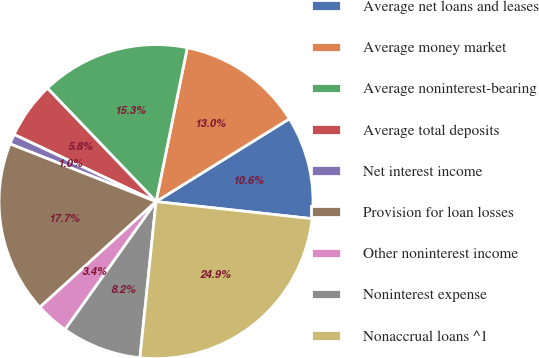Convert chart to OTSL. <chart><loc_0><loc_0><loc_500><loc_500><pie_chart><fcel>Average net loans and leases<fcel>Average money market<fcel>Average noninterest-bearing<fcel>Average total deposits<fcel>Net interest income<fcel>Provision for loan losses<fcel>Other noninterest income<fcel>Noninterest expense<fcel>Nonaccrual loans ^1<nl><fcel>10.58%<fcel>12.97%<fcel>15.35%<fcel>5.81%<fcel>1.04%<fcel>17.74%<fcel>3.42%<fcel>8.2%<fcel>24.9%<nl></chart> 